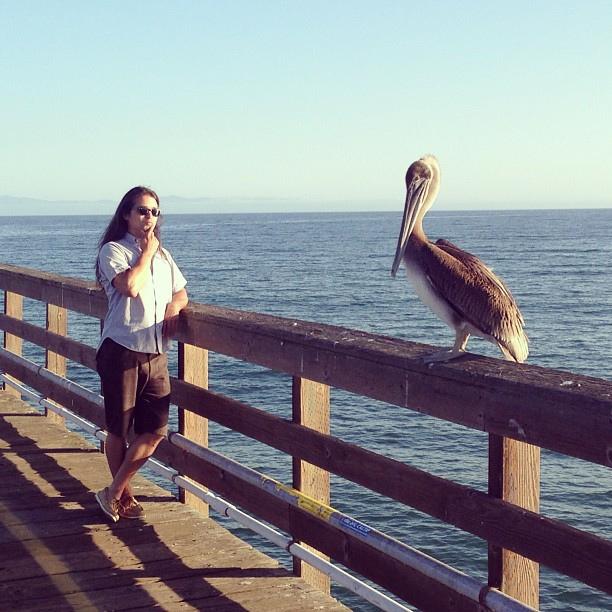What does the person have on their face?
Answer briefly. Sunglasses. Why has the pelican remained on the pier?
Give a very brief answer. Waiting to be fed. Where is the pier?
Write a very short answer. Ocean. 